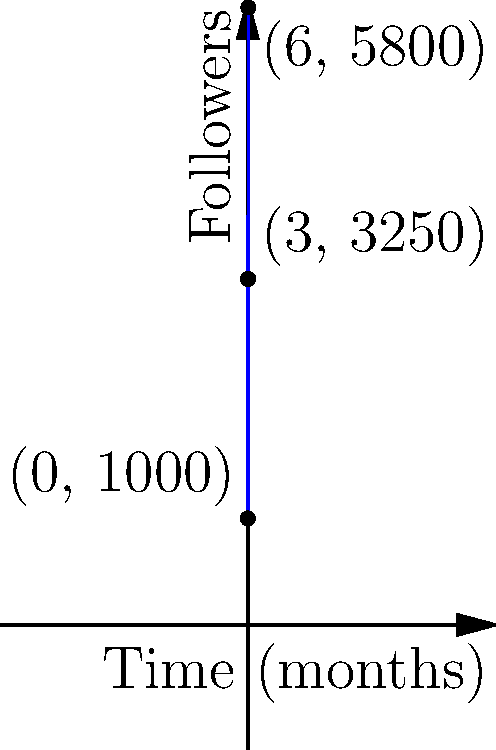The graph shows the number of followers for an emerging music genre's social media account over time. Given that the follower count $F(t)$ can be modeled by a quadratic function where $t$ is the time in months, determine the instantaneous rate of change in followers at $t = 3$ months. To find the instantaneous rate of change at $t = 3$, we need to follow these steps:

1) First, we need to find the quadratic function that models the data. The general form is:
   $F(t) = at^2 + bt + c$

2) We can use the three points given to create a system of equations:
   $(0, 1000)$: $1000 = c$
   $(3, 3250)$: $3250 = 9a + 3b + 1000$
   $(6, 5800)$: $5800 = 36a + 6b + 1000$

3) Solving this system:
   $c = 1000$
   $2250 = 9a + 3b$
   $4800 = 36a + 6b$

4) Subtracting the second equation from the third:
   $2550 = 27a + 3b$
   $750 = 9a + b$
   $b = 750 - 9a$

5) Substituting this into $2250 = 9a + 3b$:
   $2250 = 9a + 3(750 - 9a) = 9a + 2250 - 27a$
   $0 = -18a$
   $a = 0$

6) Therefore, $b = 750$ and the function is:
   $F(t) = 50t^2 + 500t + 1000$

7) The instantaneous rate of change is given by the derivative of $F(t)$ at $t = 3$:
   $F'(t) = 100t + 500$
   $F'(3) = 100(3) + 500 = 800$

Therefore, the instantaneous rate of change at $t = 3$ months is 800 followers per month.
Answer: 800 followers/month 